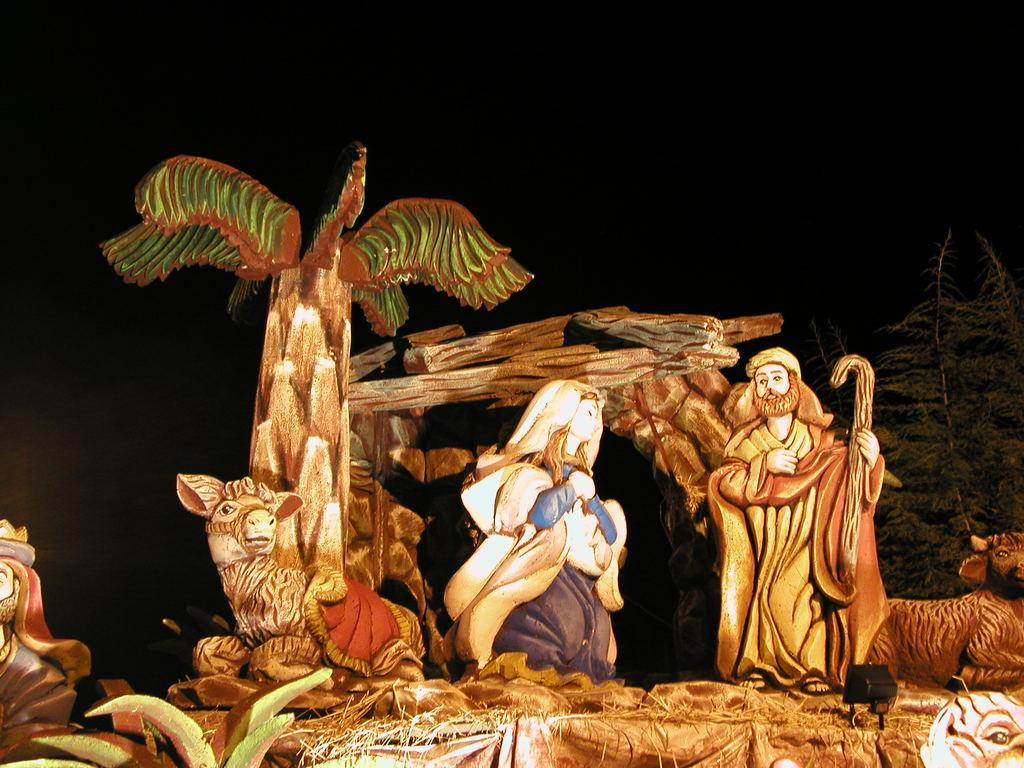What is the main subject of the image? There is an exhibition of a nativity scene in the image. What type of objects can be seen in the image? Art objects are present in the image. How would you describe the lighting in the image? The background of the image is dark. What type of trouble can be seen in the image? There is no trouble depicted in the image; it features an exhibition of a nativity scene and art objects. What season is it in the image? The image does not provide any information about the season, but it is not specifically related to summer. 